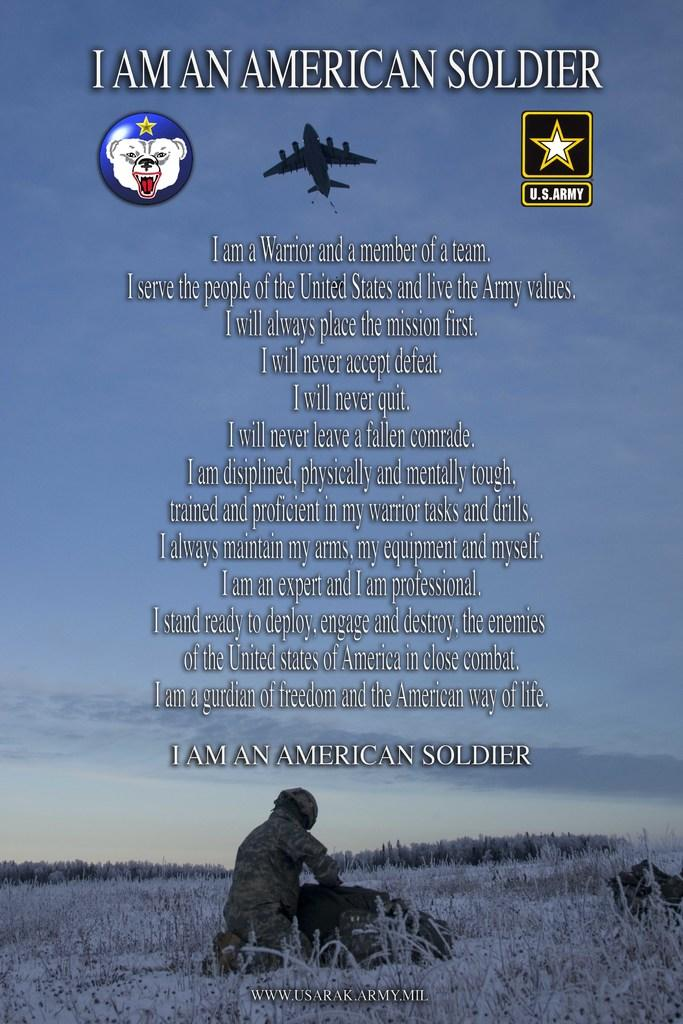<image>
Create a compact narrative representing the image presented. Advertisement by the U.S. Army with a soldier and jet in it. 